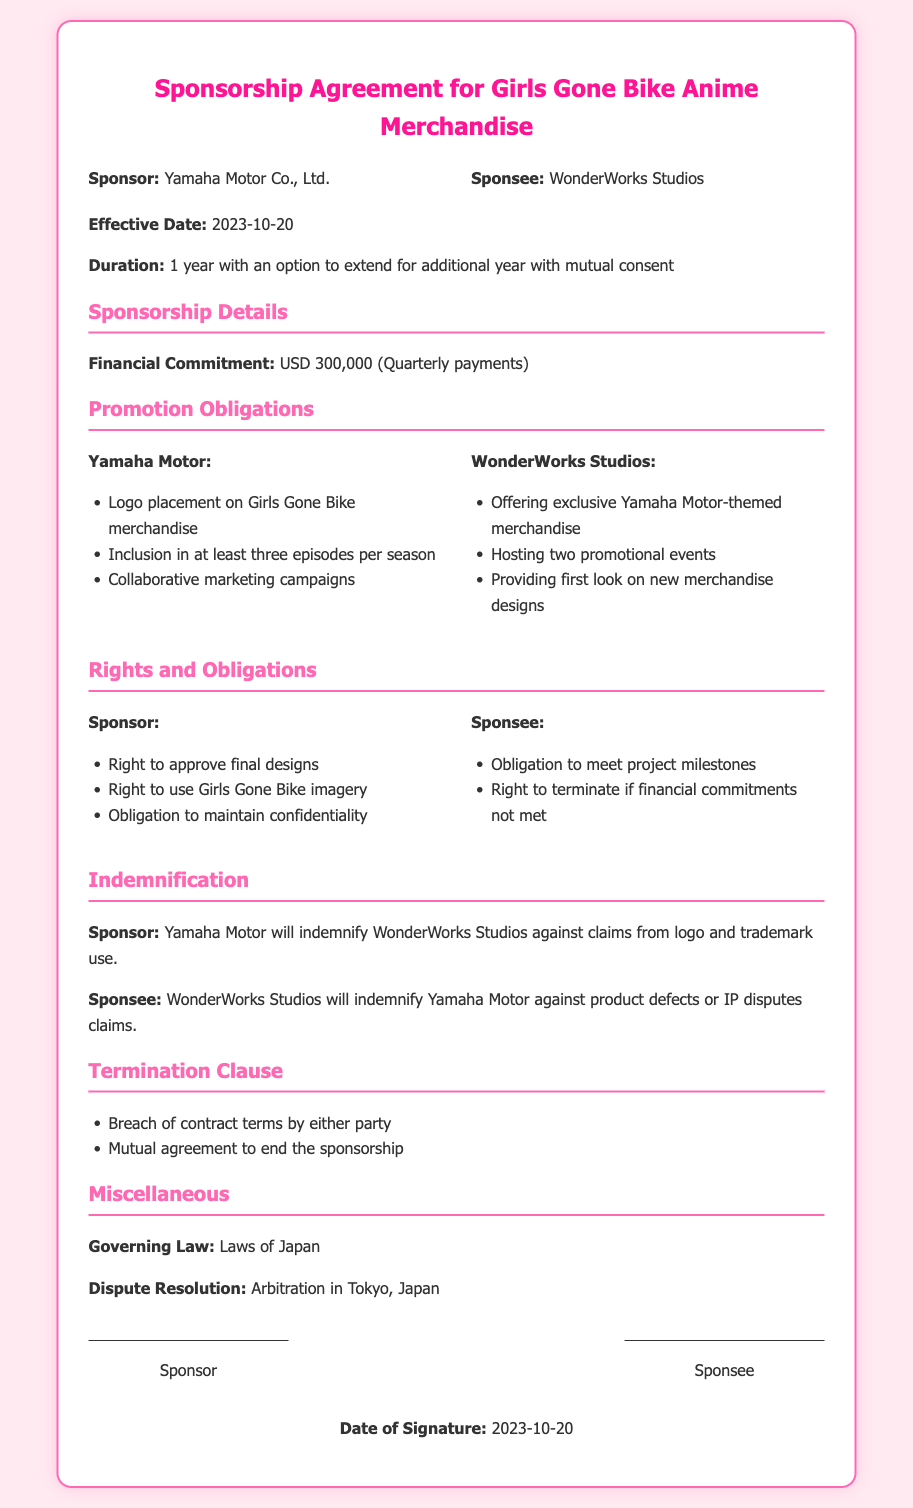What is the name of the sponsor? The sponsor is specifically mentioned in the document as Yamaha Motor Co., Ltd.
Answer: Yamaha Motor Co., Ltd What is the effective date of the agreement? The effective date is clearly stated in the document as 2023-10-20.
Answer: 2023-10-20 What is the financial commitment amount? The document specifies the financial commitment as USD 300,000.
Answer: USD 300,000 How long is the duration of the sponsorship agreement? The duration is outlined in the document as 1 year with an option to extend for an additional year with mutual consent.
Answer: 1 year What is one of the sponsor's promotional obligations? The document lists promotional obligations for Yamaha Motor, including logo placement on Girls Gone Bike merchandise.
Answer: Logo placement on Girls Gone Bike merchandise What rights does the sponsor have regarding designs? The document states that the sponsor has the right to approve final designs, which is a specific right mentioned.
Answer: Right to approve final designs Which law governs this agreement? The governing law for the sponsorship agreement is stated as the laws of Japan in the document.
Answer: Laws of Japan What is the dispute resolution method mentioned? The document outlines that arbitration will be the method for dispute resolution, specifically in Tokyo, Japan.
Answer: Arbitration in Tokyo, Japan What is one reason for termination listed in the document? One reason for termination mentioned is breach of contract terms by either party.
Answer: Breach of contract terms by either party 